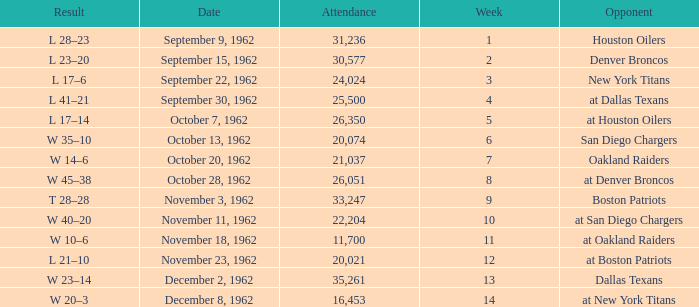What week was the attendance smaller than 22,204 on December 8, 1962? 14.0. 